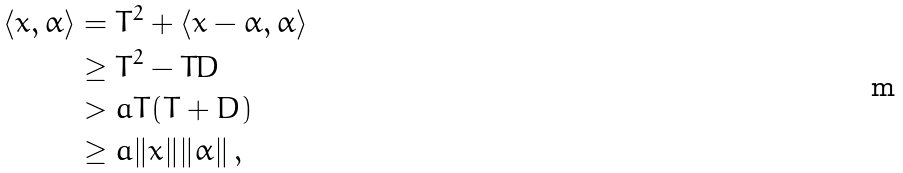Convert formula to latex. <formula><loc_0><loc_0><loc_500><loc_500>\langle x , \alpha \rangle & = T ^ { 2 } + \langle x - \alpha , \alpha \rangle \\ & \geq T ^ { 2 } - T D \\ & > a T ( T + D ) \\ & \geq a \| x \| \| \alpha \| \, ,</formula> 